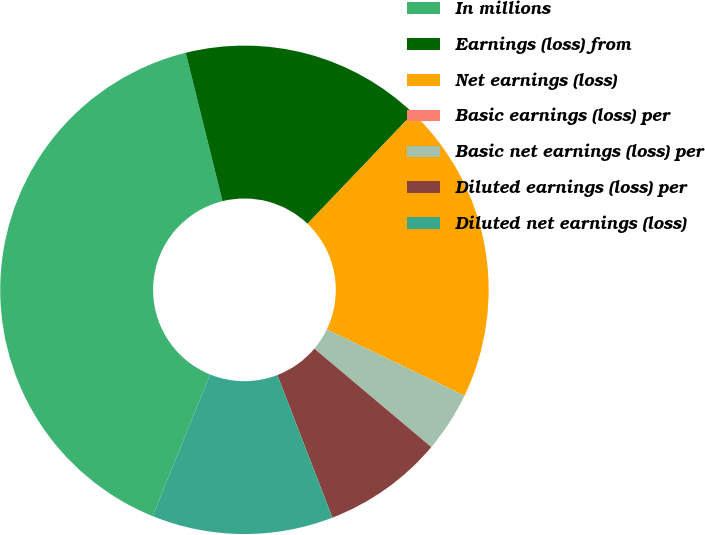<chart> <loc_0><loc_0><loc_500><loc_500><pie_chart><fcel>In millions<fcel>Earnings (loss) from<fcel>Net earnings (loss)<fcel>Basic earnings (loss) per<fcel>Basic net earnings (loss) per<fcel>Diluted earnings (loss) per<fcel>Diluted net earnings (loss)<nl><fcel>40.0%<fcel>16.0%<fcel>20.0%<fcel>0.0%<fcel>4.0%<fcel>8.0%<fcel>12.0%<nl></chart> 